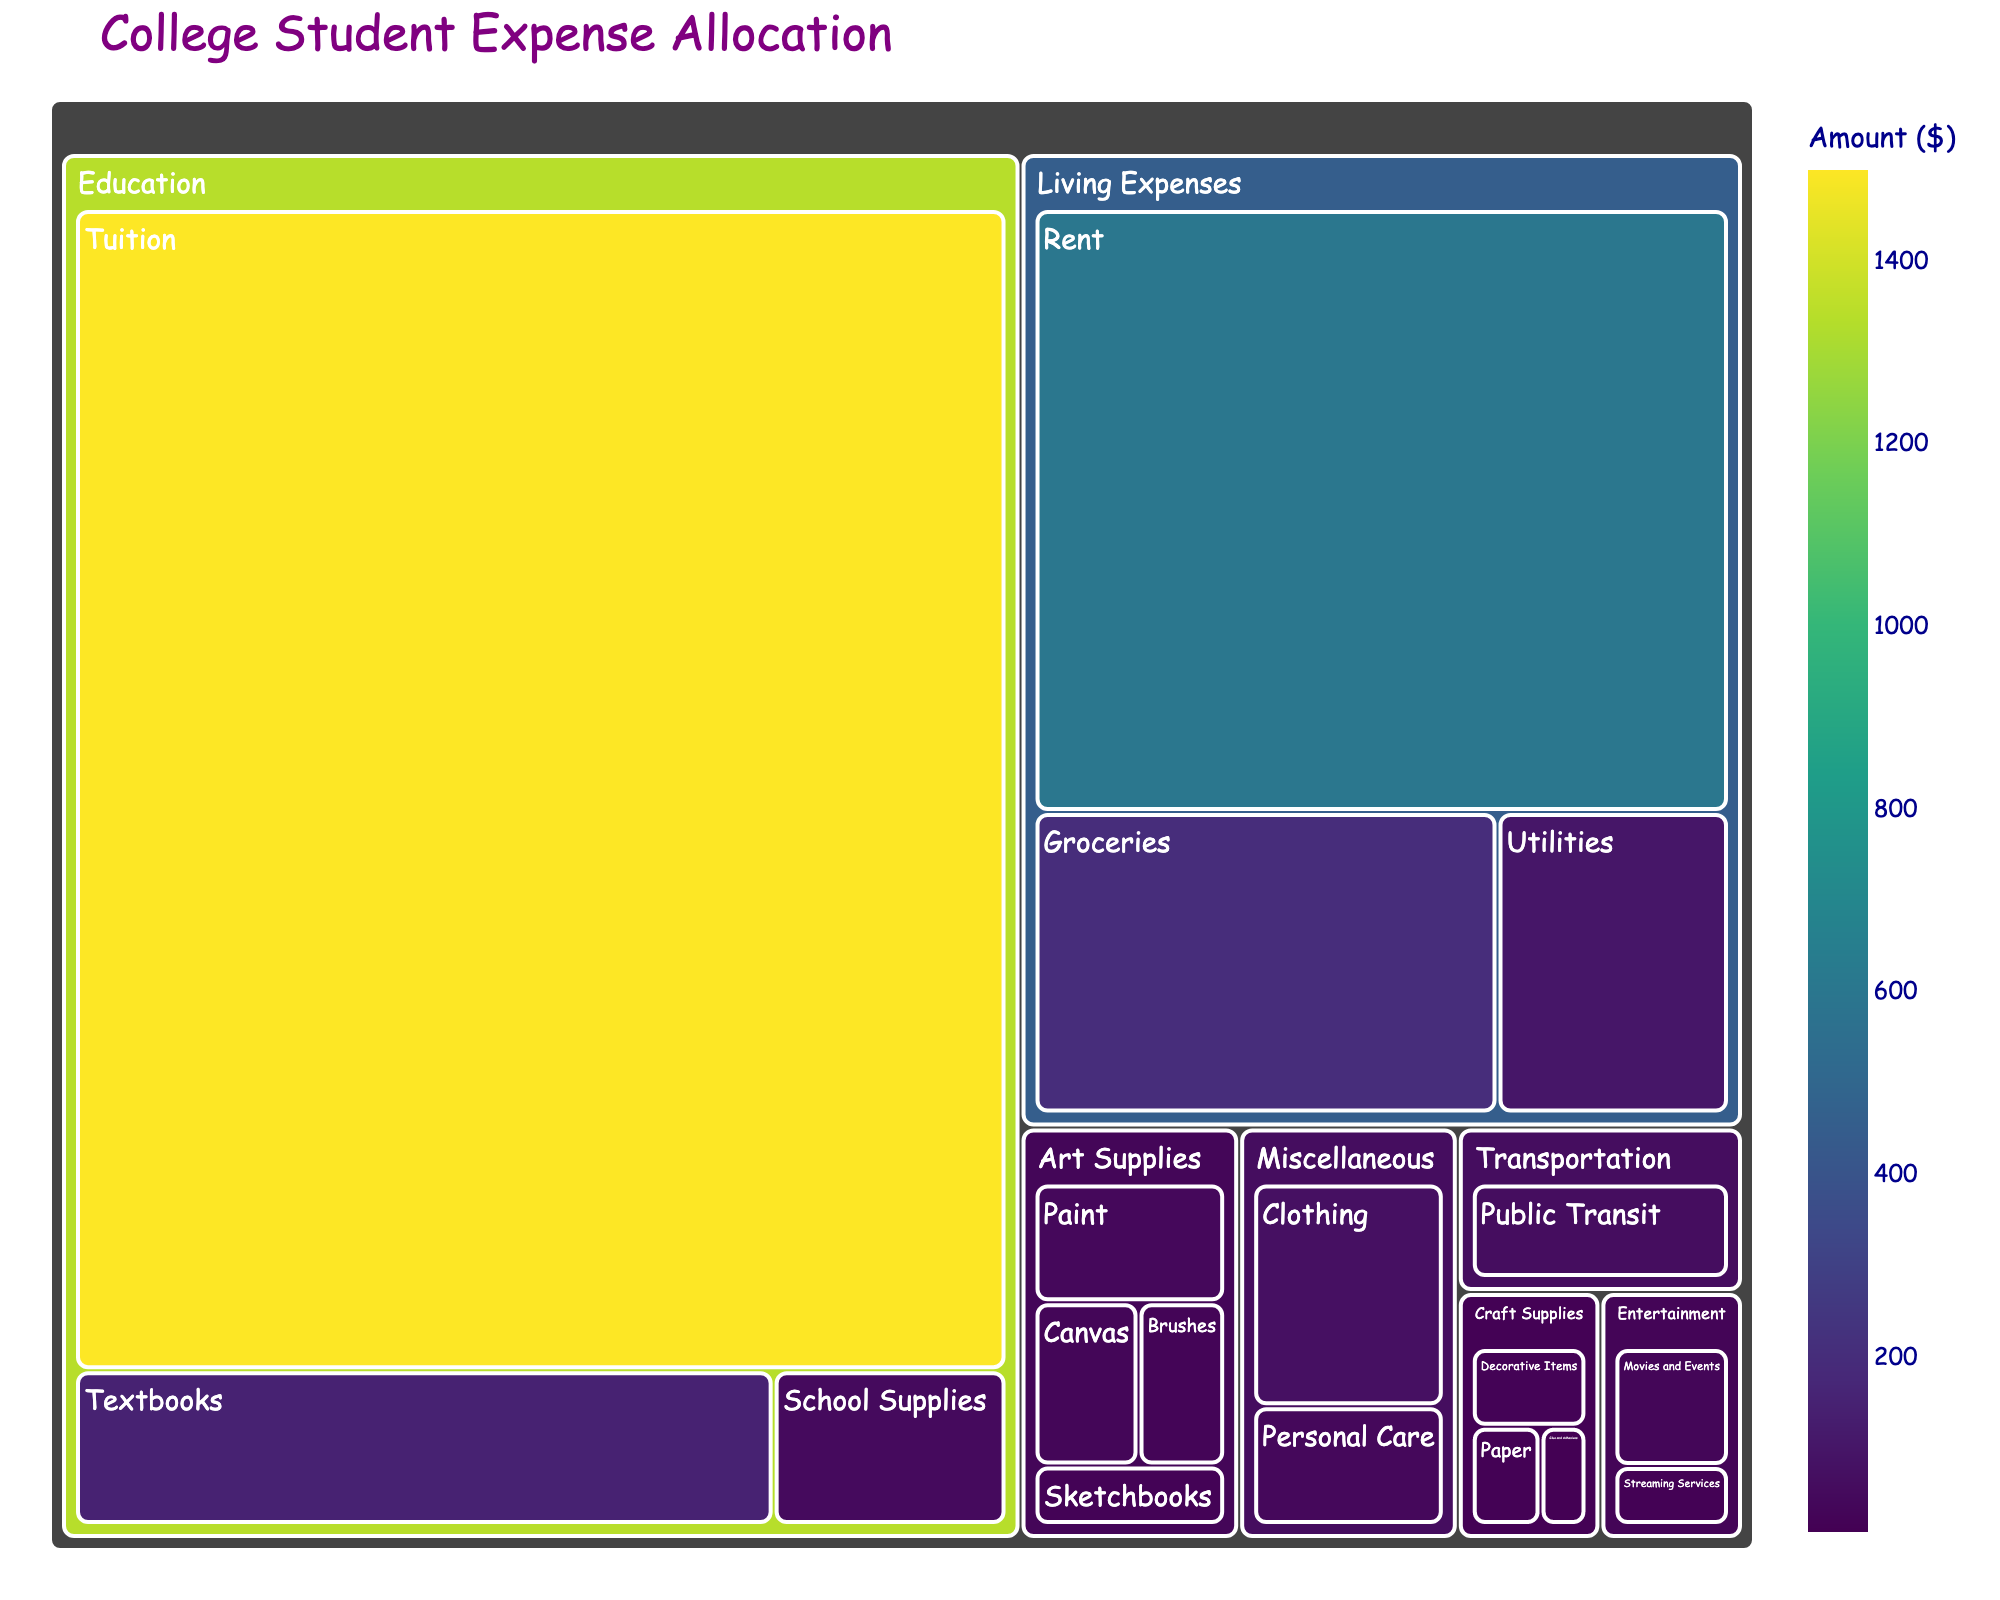What is the title of the treemap? The treemap title is typically located at the top of the visualization. From the given data, we know the title is specified as 'College Student Expense Allocation'.
Answer: College Student Expense Allocation Which category has the highest allocation amount? By examining the largest segment in the treemap, we can identify the category with the highest value. Here, 'Education' stands out as it includes 'Tuition' which is markedly higher than the other expenses at $1500.
Answer: Education How much more is spent on Rent compared to Public Transit? From the figure, Rent is $600 and Public Transit is $60. Subtracting these values gives $600 - $60 = $540.
Answer: $540 What is the total amount spent on Art Supplies? Art Supplies includes Paint ($40), Brushes ($25), Canvas ($30), and Sketchbooks ($20). Summing these values: $40 + $25 + $30 + $20 = $115.
Answer: $115 Compare the amount spent on Craft Supplies versus Entertainment. Which is higher and by how much? Craft Supplies total ($15 + $10 + $20) = $45. Entertainment total ($15 + $30) = $45. Both categories sum to the same value.
Answer: Equal, by $0 Which subcategory within Art Supplies has the lowest expense? Looking at the segments under Art Supplies, Sketchbooks have the lowest value at $20.
Answer: Sketchbooks How does the amount spent on Groceries compare to that on Textbooks? Groceries amount is $200 while Textbooks is $150. Comparing these, $200 is greater than $150 by $50.
Answer: Groceries, by $50 What percentage of the total expenses is allocated to Tuition? The total expenses sum to $2580. Tuition is $1500. The percentage is calculated: ($1500 / $2580) * 100 ≈ 58.14%.
Answer: 58.14% How many categories have at least one subcategory with an amount over $100? From the figure, these categories are 'Living Expenses' (Rent $600), 'Education' (Tuition $1500), and 'Living Expenses' (Groceries $200). Therefore, there are three such categories.
Answer: 3 